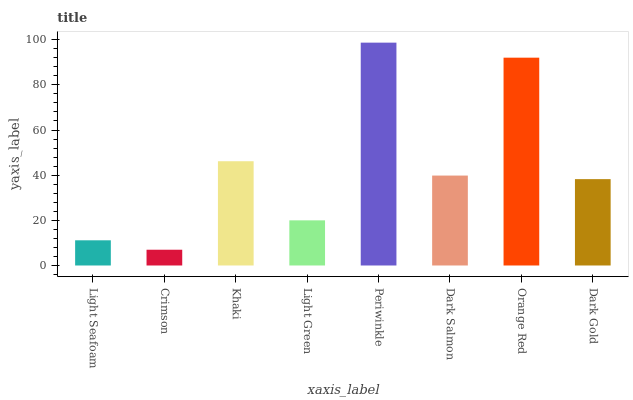Is Crimson the minimum?
Answer yes or no. Yes. Is Periwinkle the maximum?
Answer yes or no. Yes. Is Khaki the minimum?
Answer yes or no. No. Is Khaki the maximum?
Answer yes or no. No. Is Khaki greater than Crimson?
Answer yes or no. Yes. Is Crimson less than Khaki?
Answer yes or no. Yes. Is Crimson greater than Khaki?
Answer yes or no. No. Is Khaki less than Crimson?
Answer yes or no. No. Is Dark Salmon the high median?
Answer yes or no. Yes. Is Dark Gold the low median?
Answer yes or no. Yes. Is Light Seafoam the high median?
Answer yes or no. No. Is Dark Salmon the low median?
Answer yes or no. No. 